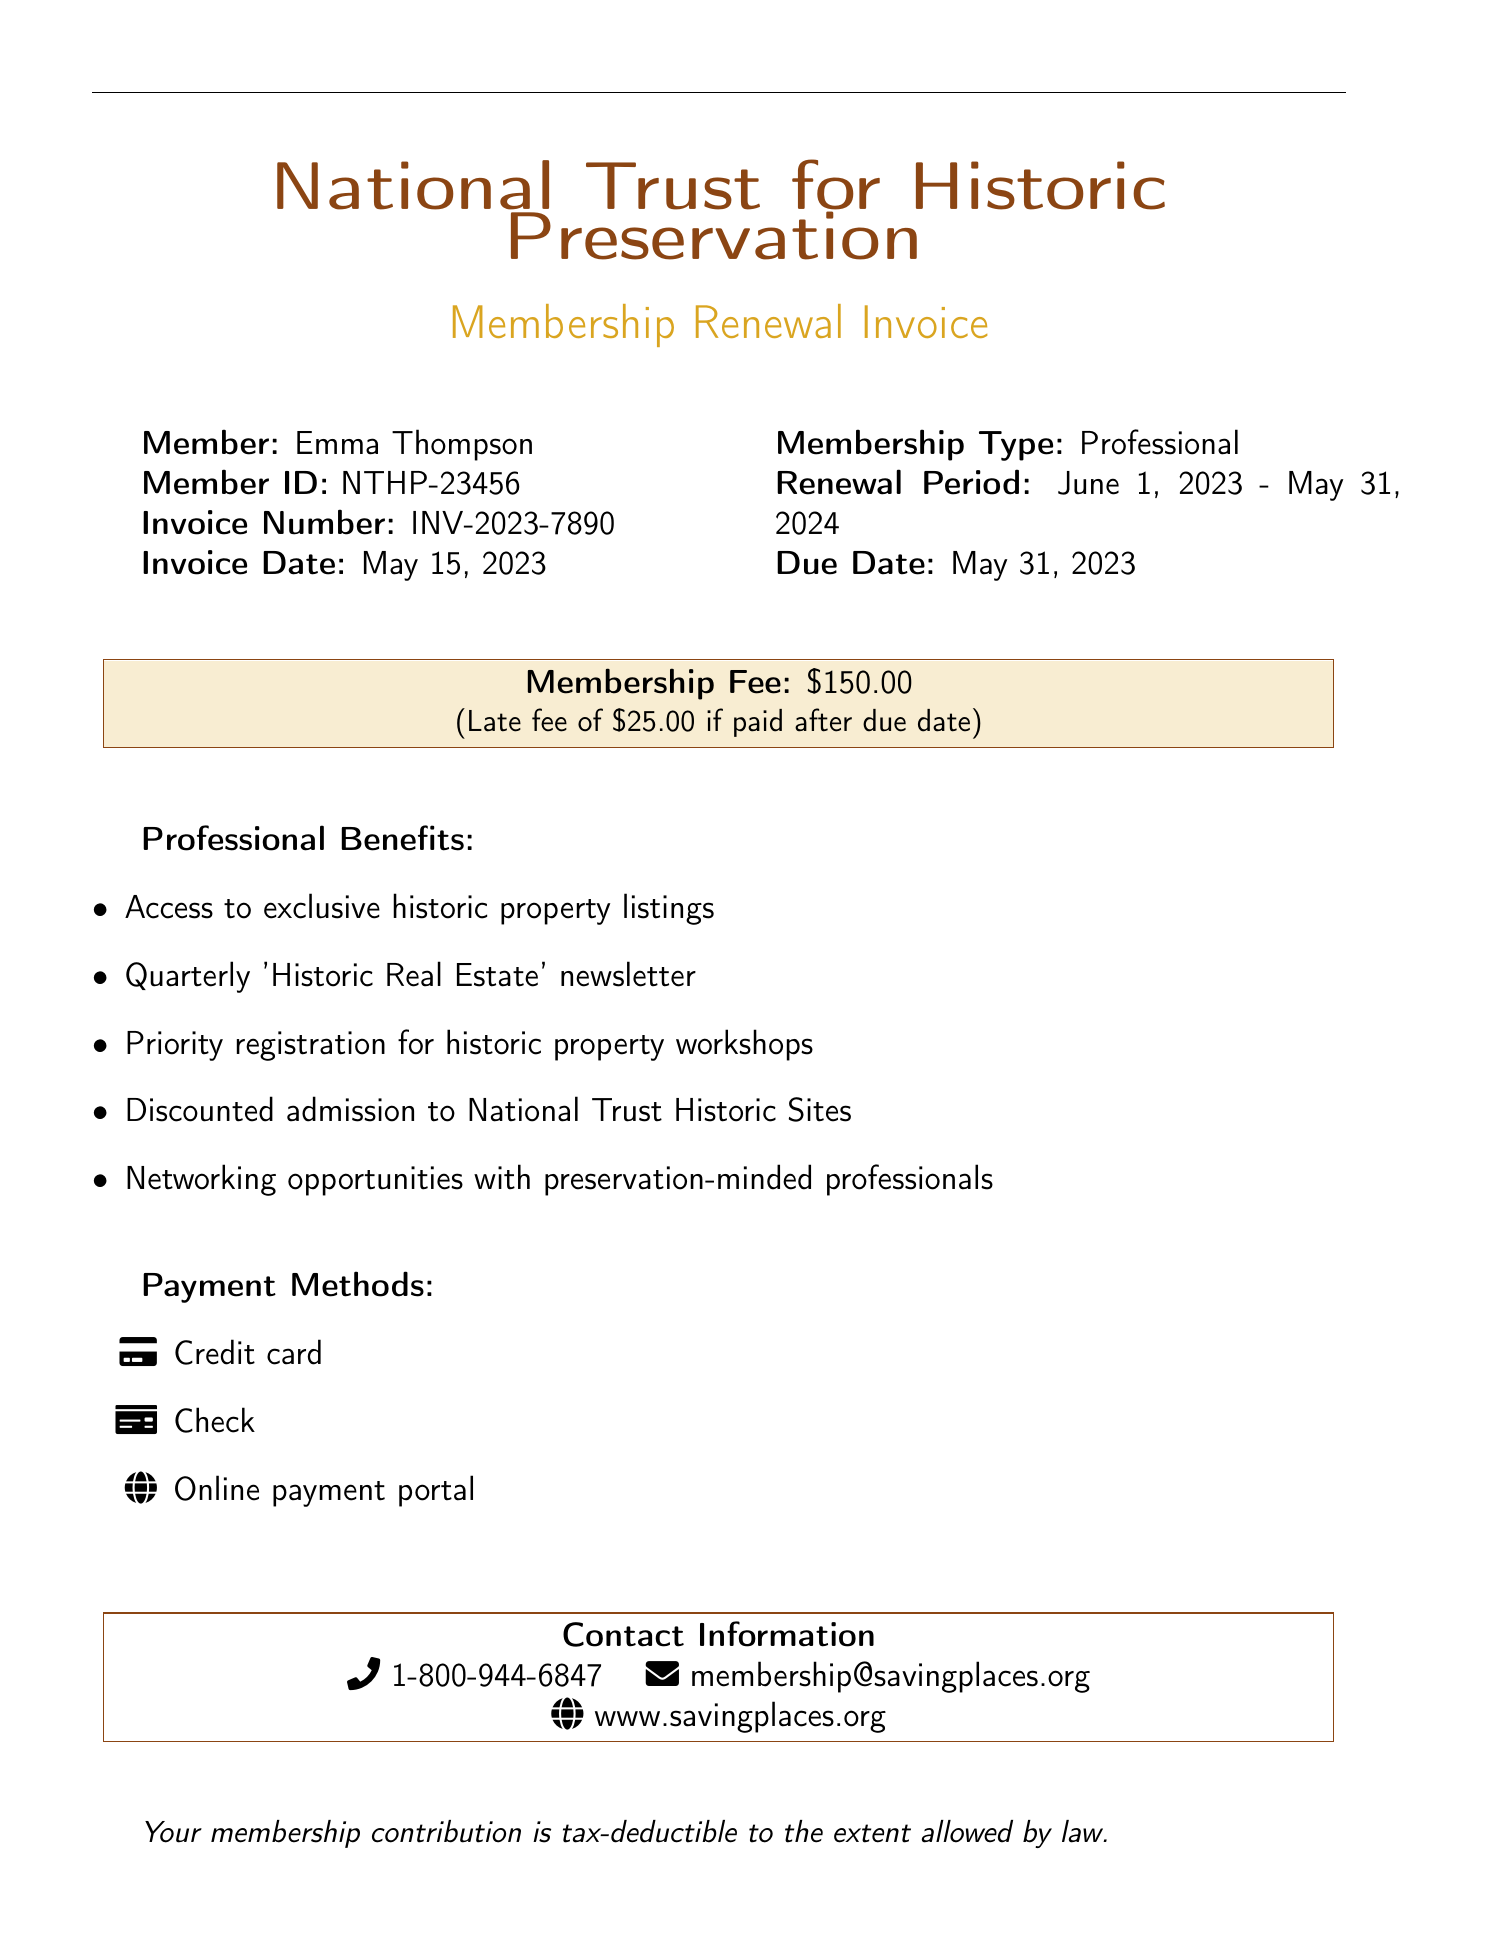What is the member's name? The member's name is listed at the top of the invoice.
Answer: Emma Thompson What is the membership type? The membership type is indicated in the document near the member's details.
Answer: Professional What is the membership fee? The membership fee is specified within a highlighted box in the document.
Answer: $150.00 What is the due date for renewal? The due date is mentioned immediately under the membership period.
Answer: May 31, 2023 What is the late fee amount? The late fee amount is mentioned in the membership fee section.
Answer: $25.00 What period does the renewal cover? The renewal period is specified near the membership type.
Answer: June 1, 2023 - May 31, 2024 How can members pay their fees? The payment methods are listed towards the end of the document.
Answer: Credit card, Check, Online payment portal What benefits are included for professionals? The benefits for professionals are listed in a bullet format under the professional benefits section.
Answer: Access to exclusive historic property listings What is the contact phone number for the National Trust? The contact phone number is provided in the contact information section.
Answer: 1-800-944-6847 What is the website for the National Trust for Historic Preservation? The website is mentioned in the contact information section.
Answer: www.savingplaces.org 